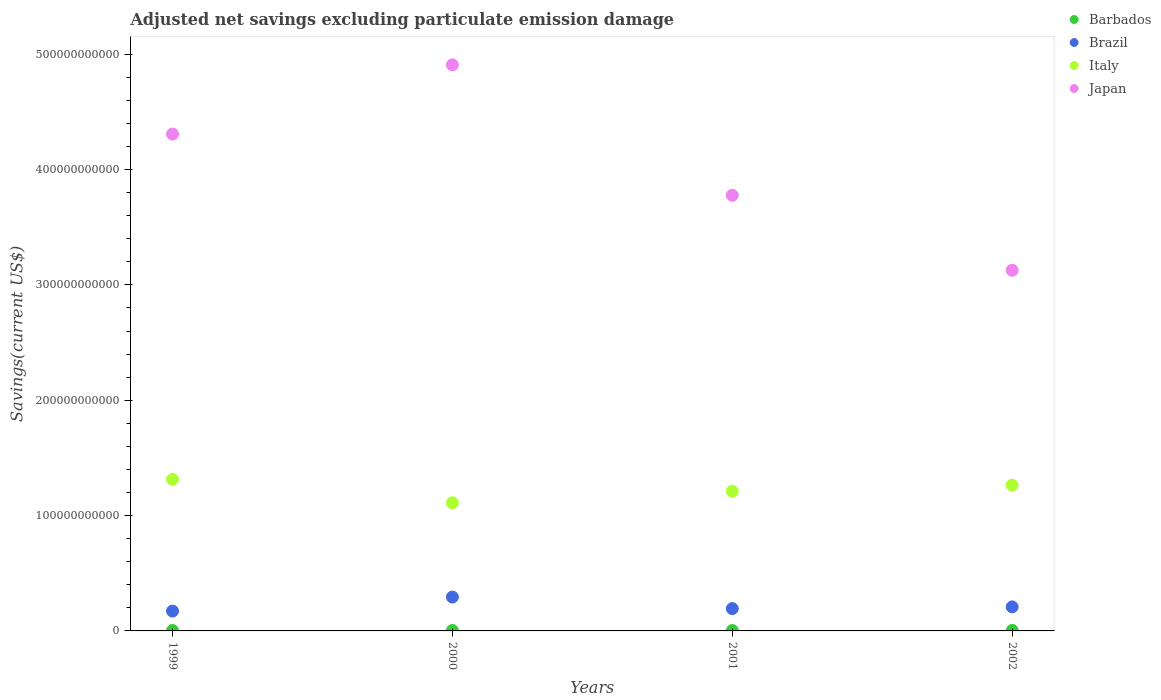How many different coloured dotlines are there?
Your answer should be very brief. 4. Is the number of dotlines equal to the number of legend labels?
Ensure brevity in your answer.  Yes. What is the adjusted net savings in Brazil in 1999?
Ensure brevity in your answer.  1.72e+1. Across all years, what is the maximum adjusted net savings in Brazil?
Keep it short and to the point. 2.94e+1. Across all years, what is the minimum adjusted net savings in Barbados?
Your response must be concise. 3.61e+08. In which year was the adjusted net savings in Brazil maximum?
Ensure brevity in your answer.  2000. What is the total adjusted net savings in Brazil in the graph?
Provide a succinct answer. 8.68e+1. What is the difference between the adjusted net savings in Italy in 2000 and that in 2001?
Offer a terse response. -1.00e+1. What is the difference between the adjusted net savings in Japan in 2002 and the adjusted net savings in Brazil in 2000?
Your answer should be very brief. 2.83e+11. What is the average adjusted net savings in Barbados per year?
Give a very brief answer. 3.94e+08. In the year 1999, what is the difference between the adjusted net savings in Japan and adjusted net savings in Brazil?
Give a very brief answer. 4.14e+11. What is the ratio of the adjusted net savings in Brazil in 2001 to that in 2002?
Your answer should be very brief. 0.93. What is the difference between the highest and the second highest adjusted net savings in Japan?
Offer a terse response. 6.00e+1. What is the difference between the highest and the lowest adjusted net savings in Brazil?
Your response must be concise. 1.22e+1. Is the sum of the adjusted net savings in Brazil in 1999 and 2000 greater than the maximum adjusted net savings in Italy across all years?
Your answer should be very brief. No. Is it the case that in every year, the sum of the adjusted net savings in Italy and adjusted net savings in Brazil  is greater than the sum of adjusted net savings in Barbados and adjusted net savings in Japan?
Offer a terse response. Yes. Is it the case that in every year, the sum of the adjusted net savings in Brazil and adjusted net savings in Barbados  is greater than the adjusted net savings in Italy?
Provide a succinct answer. No. Does the adjusted net savings in Brazil monotonically increase over the years?
Keep it short and to the point. No. Is the adjusted net savings in Barbados strictly less than the adjusted net savings in Japan over the years?
Make the answer very short. Yes. How many years are there in the graph?
Provide a succinct answer. 4. What is the difference between two consecutive major ticks on the Y-axis?
Keep it short and to the point. 1.00e+11. Does the graph contain any zero values?
Keep it short and to the point. No. Does the graph contain grids?
Keep it short and to the point. No. What is the title of the graph?
Provide a succinct answer. Adjusted net savings excluding particulate emission damage. What is the label or title of the X-axis?
Make the answer very short. Years. What is the label or title of the Y-axis?
Provide a short and direct response. Savings(current US$). What is the Savings(current US$) of Barbados in 1999?
Offer a terse response. 3.65e+08. What is the Savings(current US$) in Brazil in 1999?
Ensure brevity in your answer.  1.72e+1. What is the Savings(current US$) of Italy in 1999?
Make the answer very short. 1.31e+11. What is the Savings(current US$) in Japan in 1999?
Keep it short and to the point. 4.31e+11. What is the Savings(current US$) of Barbados in 2000?
Offer a very short reply. 4.27e+08. What is the Savings(current US$) of Brazil in 2000?
Your answer should be very brief. 2.94e+1. What is the Savings(current US$) of Italy in 2000?
Your answer should be very brief. 1.11e+11. What is the Savings(current US$) in Japan in 2000?
Your response must be concise. 4.91e+11. What is the Savings(current US$) in Barbados in 2001?
Your answer should be compact. 3.61e+08. What is the Savings(current US$) of Brazil in 2001?
Your answer should be very brief. 1.94e+1. What is the Savings(current US$) in Italy in 2001?
Your answer should be very brief. 1.21e+11. What is the Savings(current US$) in Japan in 2001?
Your response must be concise. 3.78e+11. What is the Savings(current US$) in Barbados in 2002?
Your answer should be compact. 4.23e+08. What is the Savings(current US$) in Brazil in 2002?
Your answer should be compact. 2.08e+1. What is the Savings(current US$) of Italy in 2002?
Your answer should be compact. 1.26e+11. What is the Savings(current US$) in Japan in 2002?
Your answer should be very brief. 3.13e+11. Across all years, what is the maximum Savings(current US$) of Barbados?
Make the answer very short. 4.27e+08. Across all years, what is the maximum Savings(current US$) of Brazil?
Keep it short and to the point. 2.94e+1. Across all years, what is the maximum Savings(current US$) of Italy?
Your response must be concise. 1.31e+11. Across all years, what is the maximum Savings(current US$) of Japan?
Keep it short and to the point. 4.91e+11. Across all years, what is the minimum Savings(current US$) of Barbados?
Offer a very short reply. 3.61e+08. Across all years, what is the minimum Savings(current US$) in Brazil?
Your answer should be very brief. 1.72e+1. Across all years, what is the minimum Savings(current US$) of Italy?
Give a very brief answer. 1.11e+11. Across all years, what is the minimum Savings(current US$) in Japan?
Provide a succinct answer. 3.13e+11. What is the total Savings(current US$) in Barbados in the graph?
Your response must be concise. 1.58e+09. What is the total Savings(current US$) of Brazil in the graph?
Keep it short and to the point. 8.68e+1. What is the total Savings(current US$) of Italy in the graph?
Your answer should be compact. 4.90e+11. What is the total Savings(current US$) in Japan in the graph?
Provide a short and direct response. 1.61e+12. What is the difference between the Savings(current US$) of Barbados in 1999 and that in 2000?
Your answer should be very brief. -6.27e+07. What is the difference between the Savings(current US$) in Brazil in 1999 and that in 2000?
Make the answer very short. -1.22e+1. What is the difference between the Savings(current US$) of Italy in 1999 and that in 2000?
Keep it short and to the point. 2.03e+1. What is the difference between the Savings(current US$) in Japan in 1999 and that in 2000?
Offer a terse response. -6.00e+1. What is the difference between the Savings(current US$) in Barbados in 1999 and that in 2001?
Offer a very short reply. 3.49e+06. What is the difference between the Savings(current US$) of Brazil in 1999 and that in 2001?
Give a very brief answer. -2.15e+09. What is the difference between the Savings(current US$) of Italy in 1999 and that in 2001?
Your answer should be compact. 1.03e+1. What is the difference between the Savings(current US$) in Japan in 1999 and that in 2001?
Provide a succinct answer. 5.31e+1. What is the difference between the Savings(current US$) of Barbados in 1999 and that in 2002?
Your response must be concise. -5.83e+07. What is the difference between the Savings(current US$) in Brazil in 1999 and that in 2002?
Keep it short and to the point. -3.64e+09. What is the difference between the Savings(current US$) in Italy in 1999 and that in 2002?
Your answer should be very brief. 5.06e+09. What is the difference between the Savings(current US$) in Japan in 1999 and that in 2002?
Make the answer very short. 1.18e+11. What is the difference between the Savings(current US$) of Barbados in 2000 and that in 2001?
Give a very brief answer. 6.62e+07. What is the difference between the Savings(current US$) of Brazil in 2000 and that in 2001?
Keep it short and to the point. 1.00e+1. What is the difference between the Savings(current US$) of Italy in 2000 and that in 2001?
Ensure brevity in your answer.  -1.00e+1. What is the difference between the Savings(current US$) of Japan in 2000 and that in 2001?
Your answer should be compact. 1.13e+11. What is the difference between the Savings(current US$) of Barbados in 2000 and that in 2002?
Your answer should be compact. 4.39e+06. What is the difference between the Savings(current US$) in Brazil in 2000 and that in 2002?
Provide a succinct answer. 8.52e+09. What is the difference between the Savings(current US$) in Italy in 2000 and that in 2002?
Your answer should be very brief. -1.52e+1. What is the difference between the Savings(current US$) of Japan in 2000 and that in 2002?
Keep it short and to the point. 1.78e+11. What is the difference between the Savings(current US$) of Barbados in 2001 and that in 2002?
Ensure brevity in your answer.  -6.18e+07. What is the difference between the Savings(current US$) in Brazil in 2001 and that in 2002?
Ensure brevity in your answer.  -1.49e+09. What is the difference between the Savings(current US$) of Italy in 2001 and that in 2002?
Offer a terse response. -5.23e+09. What is the difference between the Savings(current US$) in Japan in 2001 and that in 2002?
Offer a terse response. 6.50e+1. What is the difference between the Savings(current US$) of Barbados in 1999 and the Savings(current US$) of Brazil in 2000?
Offer a terse response. -2.90e+1. What is the difference between the Savings(current US$) of Barbados in 1999 and the Savings(current US$) of Italy in 2000?
Keep it short and to the point. -1.11e+11. What is the difference between the Savings(current US$) of Barbados in 1999 and the Savings(current US$) of Japan in 2000?
Offer a terse response. -4.90e+11. What is the difference between the Savings(current US$) of Brazil in 1999 and the Savings(current US$) of Italy in 2000?
Keep it short and to the point. -9.39e+1. What is the difference between the Savings(current US$) in Brazil in 1999 and the Savings(current US$) in Japan in 2000?
Make the answer very short. -4.74e+11. What is the difference between the Savings(current US$) in Italy in 1999 and the Savings(current US$) in Japan in 2000?
Offer a terse response. -3.59e+11. What is the difference between the Savings(current US$) of Barbados in 1999 and the Savings(current US$) of Brazil in 2001?
Your answer should be very brief. -1.90e+1. What is the difference between the Savings(current US$) of Barbados in 1999 and the Savings(current US$) of Italy in 2001?
Keep it short and to the point. -1.21e+11. What is the difference between the Savings(current US$) of Barbados in 1999 and the Savings(current US$) of Japan in 2001?
Offer a terse response. -3.77e+11. What is the difference between the Savings(current US$) of Brazil in 1999 and the Savings(current US$) of Italy in 2001?
Provide a succinct answer. -1.04e+11. What is the difference between the Savings(current US$) in Brazil in 1999 and the Savings(current US$) in Japan in 2001?
Keep it short and to the point. -3.60e+11. What is the difference between the Savings(current US$) in Italy in 1999 and the Savings(current US$) in Japan in 2001?
Your answer should be compact. -2.46e+11. What is the difference between the Savings(current US$) of Barbados in 1999 and the Savings(current US$) of Brazil in 2002?
Your answer should be compact. -2.05e+1. What is the difference between the Savings(current US$) of Barbados in 1999 and the Savings(current US$) of Italy in 2002?
Make the answer very short. -1.26e+11. What is the difference between the Savings(current US$) in Barbados in 1999 and the Savings(current US$) in Japan in 2002?
Your response must be concise. -3.12e+11. What is the difference between the Savings(current US$) of Brazil in 1999 and the Savings(current US$) of Italy in 2002?
Make the answer very short. -1.09e+11. What is the difference between the Savings(current US$) in Brazil in 1999 and the Savings(current US$) in Japan in 2002?
Provide a short and direct response. -2.95e+11. What is the difference between the Savings(current US$) in Italy in 1999 and the Savings(current US$) in Japan in 2002?
Make the answer very short. -1.81e+11. What is the difference between the Savings(current US$) in Barbados in 2000 and the Savings(current US$) in Brazil in 2001?
Provide a short and direct response. -1.89e+1. What is the difference between the Savings(current US$) in Barbados in 2000 and the Savings(current US$) in Italy in 2001?
Provide a succinct answer. -1.21e+11. What is the difference between the Savings(current US$) of Barbados in 2000 and the Savings(current US$) of Japan in 2001?
Your answer should be compact. -3.77e+11. What is the difference between the Savings(current US$) in Brazil in 2000 and the Savings(current US$) in Italy in 2001?
Offer a very short reply. -9.18e+1. What is the difference between the Savings(current US$) of Brazil in 2000 and the Savings(current US$) of Japan in 2001?
Give a very brief answer. -3.48e+11. What is the difference between the Savings(current US$) in Italy in 2000 and the Savings(current US$) in Japan in 2001?
Provide a short and direct response. -2.67e+11. What is the difference between the Savings(current US$) of Barbados in 2000 and the Savings(current US$) of Brazil in 2002?
Offer a terse response. -2.04e+1. What is the difference between the Savings(current US$) in Barbados in 2000 and the Savings(current US$) in Italy in 2002?
Your answer should be compact. -1.26e+11. What is the difference between the Savings(current US$) of Barbados in 2000 and the Savings(current US$) of Japan in 2002?
Provide a short and direct response. -3.12e+11. What is the difference between the Savings(current US$) of Brazil in 2000 and the Savings(current US$) of Italy in 2002?
Provide a short and direct response. -9.70e+1. What is the difference between the Savings(current US$) of Brazil in 2000 and the Savings(current US$) of Japan in 2002?
Offer a terse response. -2.83e+11. What is the difference between the Savings(current US$) of Italy in 2000 and the Savings(current US$) of Japan in 2002?
Offer a very short reply. -2.02e+11. What is the difference between the Savings(current US$) in Barbados in 2001 and the Savings(current US$) in Brazil in 2002?
Ensure brevity in your answer.  -2.05e+1. What is the difference between the Savings(current US$) of Barbados in 2001 and the Savings(current US$) of Italy in 2002?
Ensure brevity in your answer.  -1.26e+11. What is the difference between the Savings(current US$) in Barbados in 2001 and the Savings(current US$) in Japan in 2002?
Keep it short and to the point. -3.12e+11. What is the difference between the Savings(current US$) in Brazil in 2001 and the Savings(current US$) in Italy in 2002?
Make the answer very short. -1.07e+11. What is the difference between the Savings(current US$) of Brazil in 2001 and the Savings(current US$) of Japan in 2002?
Offer a very short reply. -2.93e+11. What is the difference between the Savings(current US$) in Italy in 2001 and the Savings(current US$) in Japan in 2002?
Make the answer very short. -1.92e+11. What is the average Savings(current US$) in Barbados per year?
Provide a short and direct response. 3.94e+08. What is the average Savings(current US$) in Brazil per year?
Keep it short and to the point. 2.17e+1. What is the average Savings(current US$) in Italy per year?
Your answer should be compact. 1.22e+11. What is the average Savings(current US$) of Japan per year?
Give a very brief answer. 4.03e+11. In the year 1999, what is the difference between the Savings(current US$) in Barbados and Savings(current US$) in Brazil?
Provide a succinct answer. -1.68e+1. In the year 1999, what is the difference between the Savings(current US$) of Barbados and Savings(current US$) of Italy?
Keep it short and to the point. -1.31e+11. In the year 1999, what is the difference between the Savings(current US$) of Barbados and Savings(current US$) of Japan?
Your answer should be very brief. -4.30e+11. In the year 1999, what is the difference between the Savings(current US$) in Brazil and Savings(current US$) in Italy?
Ensure brevity in your answer.  -1.14e+11. In the year 1999, what is the difference between the Savings(current US$) of Brazil and Savings(current US$) of Japan?
Give a very brief answer. -4.14e+11. In the year 1999, what is the difference between the Savings(current US$) in Italy and Savings(current US$) in Japan?
Make the answer very short. -2.99e+11. In the year 2000, what is the difference between the Savings(current US$) of Barbados and Savings(current US$) of Brazil?
Your answer should be compact. -2.89e+1. In the year 2000, what is the difference between the Savings(current US$) of Barbados and Savings(current US$) of Italy?
Give a very brief answer. -1.11e+11. In the year 2000, what is the difference between the Savings(current US$) in Barbados and Savings(current US$) in Japan?
Keep it short and to the point. -4.90e+11. In the year 2000, what is the difference between the Savings(current US$) in Brazil and Savings(current US$) in Italy?
Offer a terse response. -8.17e+1. In the year 2000, what is the difference between the Savings(current US$) in Brazil and Savings(current US$) in Japan?
Offer a terse response. -4.61e+11. In the year 2000, what is the difference between the Savings(current US$) in Italy and Savings(current US$) in Japan?
Make the answer very short. -3.80e+11. In the year 2001, what is the difference between the Savings(current US$) in Barbados and Savings(current US$) in Brazil?
Ensure brevity in your answer.  -1.90e+1. In the year 2001, what is the difference between the Savings(current US$) of Barbados and Savings(current US$) of Italy?
Your answer should be very brief. -1.21e+11. In the year 2001, what is the difference between the Savings(current US$) in Barbados and Savings(current US$) in Japan?
Give a very brief answer. -3.77e+11. In the year 2001, what is the difference between the Savings(current US$) in Brazil and Savings(current US$) in Italy?
Offer a terse response. -1.02e+11. In the year 2001, what is the difference between the Savings(current US$) of Brazil and Savings(current US$) of Japan?
Make the answer very short. -3.58e+11. In the year 2001, what is the difference between the Savings(current US$) of Italy and Savings(current US$) of Japan?
Provide a short and direct response. -2.57e+11. In the year 2002, what is the difference between the Savings(current US$) of Barbados and Savings(current US$) of Brazil?
Give a very brief answer. -2.04e+1. In the year 2002, what is the difference between the Savings(current US$) of Barbados and Savings(current US$) of Italy?
Your answer should be compact. -1.26e+11. In the year 2002, what is the difference between the Savings(current US$) of Barbados and Savings(current US$) of Japan?
Offer a terse response. -3.12e+11. In the year 2002, what is the difference between the Savings(current US$) in Brazil and Savings(current US$) in Italy?
Your answer should be very brief. -1.06e+11. In the year 2002, what is the difference between the Savings(current US$) of Brazil and Savings(current US$) of Japan?
Keep it short and to the point. -2.92e+11. In the year 2002, what is the difference between the Savings(current US$) in Italy and Savings(current US$) in Japan?
Provide a succinct answer. -1.86e+11. What is the ratio of the Savings(current US$) in Barbados in 1999 to that in 2000?
Offer a terse response. 0.85. What is the ratio of the Savings(current US$) of Brazil in 1999 to that in 2000?
Keep it short and to the point. 0.59. What is the ratio of the Savings(current US$) of Italy in 1999 to that in 2000?
Ensure brevity in your answer.  1.18. What is the ratio of the Savings(current US$) of Japan in 1999 to that in 2000?
Offer a very short reply. 0.88. What is the ratio of the Savings(current US$) of Barbados in 1999 to that in 2001?
Your response must be concise. 1.01. What is the ratio of the Savings(current US$) in Brazil in 1999 to that in 2001?
Offer a terse response. 0.89. What is the ratio of the Savings(current US$) in Italy in 1999 to that in 2001?
Make the answer very short. 1.08. What is the ratio of the Savings(current US$) of Japan in 1999 to that in 2001?
Provide a short and direct response. 1.14. What is the ratio of the Savings(current US$) of Barbados in 1999 to that in 2002?
Your answer should be very brief. 0.86. What is the ratio of the Savings(current US$) of Brazil in 1999 to that in 2002?
Provide a succinct answer. 0.83. What is the ratio of the Savings(current US$) in Italy in 1999 to that in 2002?
Make the answer very short. 1.04. What is the ratio of the Savings(current US$) in Japan in 1999 to that in 2002?
Provide a short and direct response. 1.38. What is the ratio of the Savings(current US$) in Barbados in 2000 to that in 2001?
Your response must be concise. 1.18. What is the ratio of the Savings(current US$) of Brazil in 2000 to that in 2001?
Offer a very short reply. 1.52. What is the ratio of the Savings(current US$) of Italy in 2000 to that in 2001?
Offer a terse response. 0.92. What is the ratio of the Savings(current US$) of Japan in 2000 to that in 2001?
Your answer should be compact. 1.3. What is the ratio of the Savings(current US$) in Barbados in 2000 to that in 2002?
Provide a short and direct response. 1.01. What is the ratio of the Savings(current US$) of Brazil in 2000 to that in 2002?
Give a very brief answer. 1.41. What is the ratio of the Savings(current US$) in Italy in 2000 to that in 2002?
Provide a succinct answer. 0.88. What is the ratio of the Savings(current US$) in Japan in 2000 to that in 2002?
Offer a terse response. 1.57. What is the ratio of the Savings(current US$) in Barbados in 2001 to that in 2002?
Your answer should be very brief. 0.85. What is the ratio of the Savings(current US$) in Brazil in 2001 to that in 2002?
Offer a terse response. 0.93. What is the ratio of the Savings(current US$) of Italy in 2001 to that in 2002?
Offer a terse response. 0.96. What is the ratio of the Savings(current US$) in Japan in 2001 to that in 2002?
Ensure brevity in your answer.  1.21. What is the difference between the highest and the second highest Savings(current US$) of Barbados?
Make the answer very short. 4.39e+06. What is the difference between the highest and the second highest Savings(current US$) in Brazil?
Your answer should be compact. 8.52e+09. What is the difference between the highest and the second highest Savings(current US$) of Italy?
Your answer should be compact. 5.06e+09. What is the difference between the highest and the second highest Savings(current US$) in Japan?
Keep it short and to the point. 6.00e+1. What is the difference between the highest and the lowest Savings(current US$) in Barbados?
Make the answer very short. 6.62e+07. What is the difference between the highest and the lowest Savings(current US$) in Brazil?
Ensure brevity in your answer.  1.22e+1. What is the difference between the highest and the lowest Savings(current US$) of Italy?
Give a very brief answer. 2.03e+1. What is the difference between the highest and the lowest Savings(current US$) in Japan?
Give a very brief answer. 1.78e+11. 